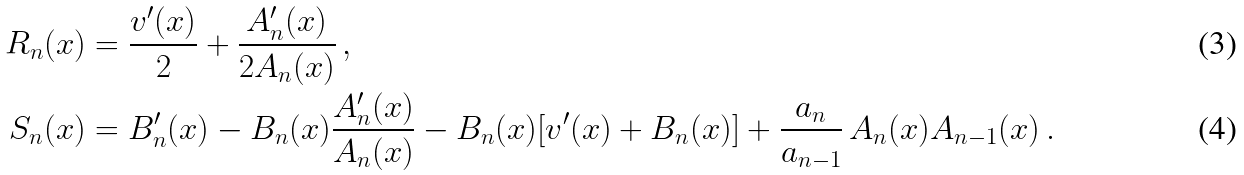<formula> <loc_0><loc_0><loc_500><loc_500>R _ { n } ( x ) & = \frac { v ^ { \prime } ( x ) } { 2 } + \frac { A ^ { \prime } _ { n } ( x ) } { 2 A _ { n } ( x ) } \, , \\ S _ { n } ( x ) & = B ^ { \prime } _ { n } ( x ) - B _ { n } ( x ) \frac { A ^ { \prime } _ { n } ( x ) } { A _ { n } ( x ) } - B _ { n } ( x ) [ v ^ { \prime } ( x ) + B _ { n } ( x ) ] + \frac { a _ { n } } { a _ { n - 1 } } \, A _ { n } ( x ) A _ { n - 1 } ( x ) \, .</formula> 